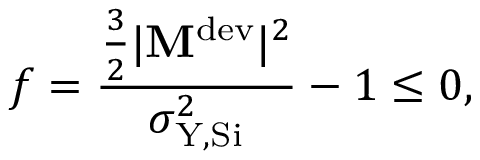<formula> <loc_0><loc_0><loc_500><loc_500>f = \frac { \frac { 3 } { 2 } | M ^ { d e v } | ^ { 2 } } { \sigma _ { Y , S i } ^ { 2 } } - 1 \leq 0 ,</formula> 